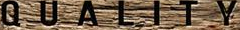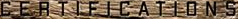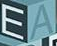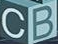Identify the words shown in these images in order, separated by a semicolon. QUALITY; CERTIFICATIONS; EA; CB 